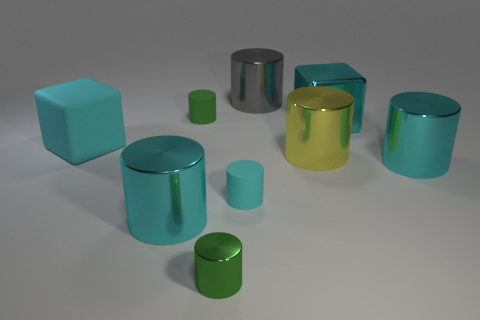There is a thing that is behind the large metal block and left of the big gray metallic cylinder; what size is it?
Make the answer very short. Small. What color is the cylinder that is both to the left of the small cyan matte cylinder and behind the big rubber object?
Your response must be concise. Green. Is there any other thing that is the same material as the large gray object?
Your answer should be very brief. Yes. Are there fewer large matte blocks that are on the left side of the small green matte cylinder than large cylinders that are behind the tiny cyan object?
Give a very brief answer. Yes. Are there any other things that have the same color as the big metal cube?
Your answer should be compact. Yes. The big cyan matte object has what shape?
Give a very brief answer. Cube. There is a large block that is the same material as the gray cylinder; what is its color?
Ensure brevity in your answer.  Cyan. Is the number of gray metallic things greater than the number of small green cylinders?
Your response must be concise. No. Are there any purple objects?
Make the answer very short. No. There is a tiny thing that is behind the big cyan shiny cylinder behind the tiny cyan matte object; what shape is it?
Give a very brief answer. Cylinder. 